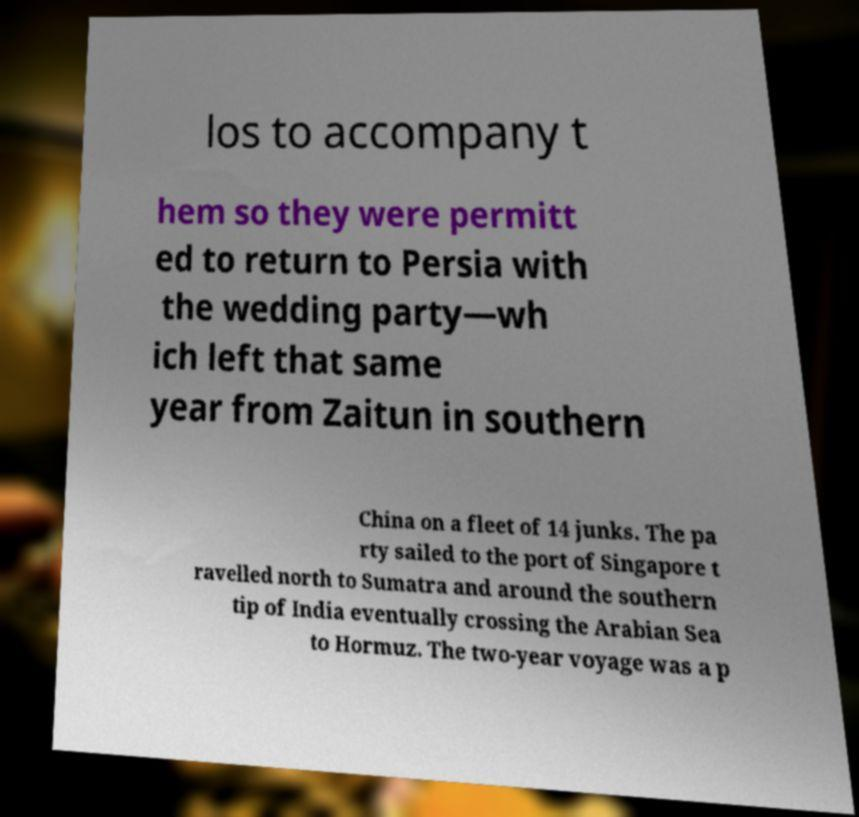Can you read and provide the text displayed in the image?This photo seems to have some interesting text. Can you extract and type it out for me? los to accompany t hem so they were permitt ed to return to Persia with the wedding party—wh ich left that same year from Zaitun in southern China on a fleet of 14 junks. The pa rty sailed to the port of Singapore t ravelled north to Sumatra and around the southern tip of India eventually crossing the Arabian Sea to Hormuz. The two-year voyage was a p 